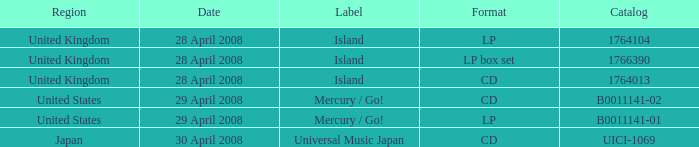What is the area of the 1766390 catalog? United Kingdom. 